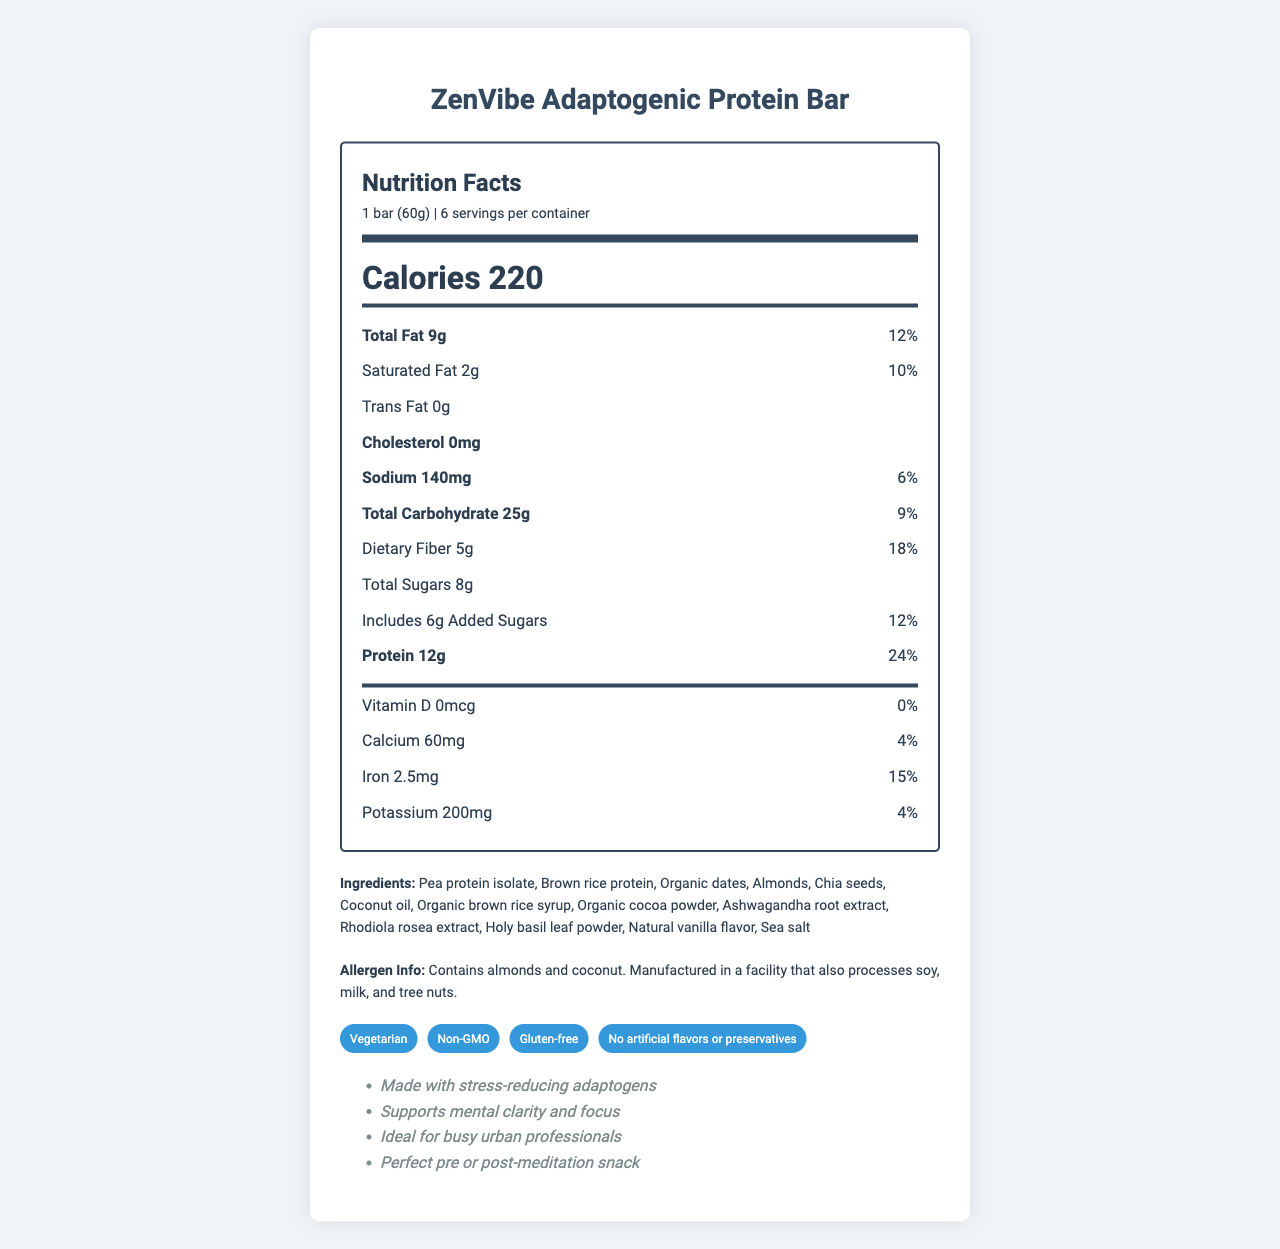what is the serving size of the ZenVibe Adaptogenic Protein Bar? The serving size is specified under the header "Nutrition Facts," indicating "1 bar (60g)."
Answer: 1 bar (60g) how many calories does one serving contain? The calorie content per serving is displayed prominently in bold under the "Calories" section.
Answer: 220 how much total fat is in each bar? The amount of total fat is listed under the nutrient section as "Total Fat 9g."
Answer: 9g what percentage of the daily value for protein does one bar provide? The daily value percentage for protein is stated next to the protein amount, indicating "24%."
Answer: 24% name three of the adaptogens included in the ingredients of the bar. The ingredient list includes adaptogens such as Ashwagandha root extract, Rhodiola rosea extract, and Holy basil leaf powder.
Answer: Ashwagandha root extract, Rhodiola rosea extract, Holy basil leaf powder which of the following nutrients has the highest daily value percentage in one bar? A. Calcium B. Iron C. Sodium D. Vitamin D Iron has a daily value percentage of 15%, which is the highest among the listed options.
Answer: B. Iron which of the following claims is NOT made about the ZenVibe Adaptogenic Protein Bar? I. Non-GMO II. Vegan III. Gluten-free IV. No artificial flavors or preservatives The claims section lists "Vegetarian," "Non-GMO," "Gluten-free," and "No artificial flavors or preservatives," but not "Vegan."
Answer: II. Vegan does the protein bar contain any added sugars? According to the nutrient section, the bar includes "Includes 6g Added Sugars."
Answer: Yes is the ZenVibe Adaptogenic Protein Bar a suitable snack for people with peanut allergies? The allergen information notes it contains almonds and coconut, but does not mention peanuts.
Answer: Yes summarize the main idea of the document. The whole document is dedicated to giving a comprehensive breakdown of the ZenVibe Adaptogenic Protein Bar, highlighting its nutritional benefits, key ingredients, allergen information, and special claims like being vegetarian and made with adaptogens.
Answer: The document provides a detailed overview of the ZenVibe Adaptogenic Protein Bar, including its nutrition facts, ingredients, allergens, product claims, and additional information such as its adaptogenic benefits and ideal usage. what are the benefits of the adaptogens included in the ZenVibe Adaptogenic Protein Bar? The document mentions that the bar is made with stress-reducing adaptogens and supports mental clarity and focus, but does not provide specific benefits of each adaptogen included.
Answer: Not enough information 